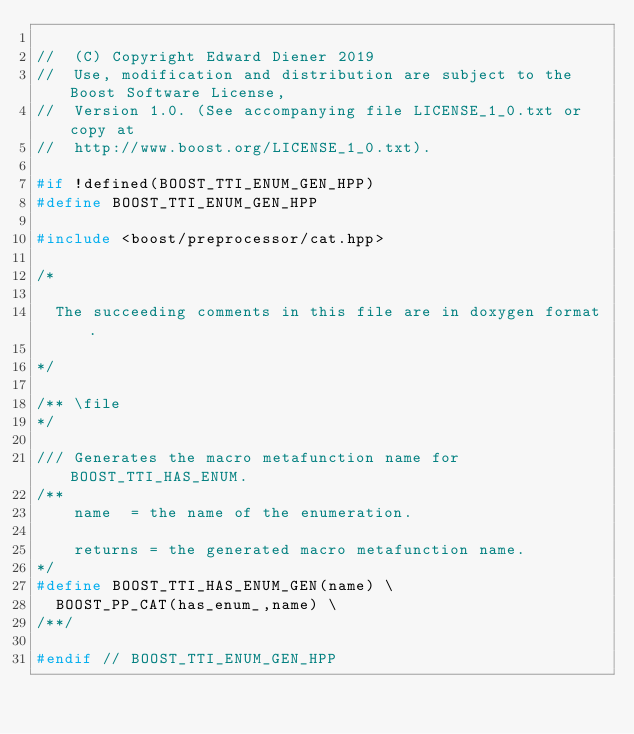<code> <loc_0><loc_0><loc_500><loc_500><_C++_>
//  (C) Copyright Edward Diener 2019
//  Use, modification and distribution are subject to the Boost Software License,
//  Version 1.0. (See accompanying file LICENSE_1_0.txt or copy at
//  http://www.boost.org/LICENSE_1_0.txt).

#if !defined(BOOST_TTI_ENUM_GEN_HPP)
#define BOOST_TTI_ENUM_GEN_HPP

#include <boost/preprocessor/cat.hpp>

/*

  The succeeding comments in this file are in doxygen format.

*/

/** \file
*/

/// Generates the macro metafunction name for BOOST_TTI_HAS_ENUM.
/**
    name  = the name of the enumeration.

    returns = the generated macro metafunction name.
*/
#define BOOST_TTI_HAS_ENUM_GEN(name) \
  BOOST_PP_CAT(has_enum_,name) \
/**/

#endif // BOOST_TTI_ENUM_GEN_HPP
</code> 